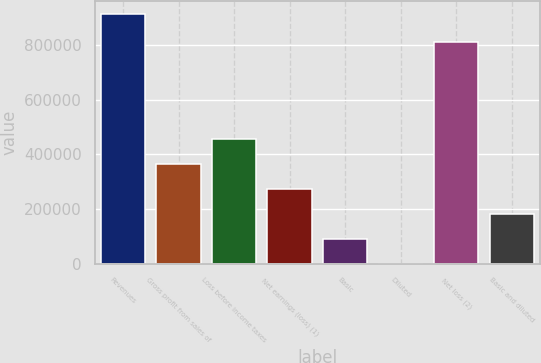<chart> <loc_0><loc_0><loc_500><loc_500><bar_chart><fcel>Revenues<fcel>Gross profit from sales of<fcel>Loss before income taxes<fcel>Net earnings (loss) (1)<fcel>Basic<fcel>Diluted<fcel>Net loss (2)<fcel>Basic and diluted<nl><fcel>913741<fcel>365497<fcel>456871<fcel>274122<fcel>91374.3<fcel>0.19<fcel>810989<fcel>182748<nl></chart> 